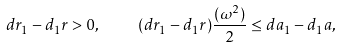Convert formula to latex. <formula><loc_0><loc_0><loc_500><loc_500>d r _ { 1 } - d _ { 1 } r > 0 , \quad ( d r _ { 1 } - d _ { 1 } r ) \frac { ( \omega ^ { 2 } ) } { 2 } \leq d a _ { 1 } - d _ { 1 } a ,</formula> 